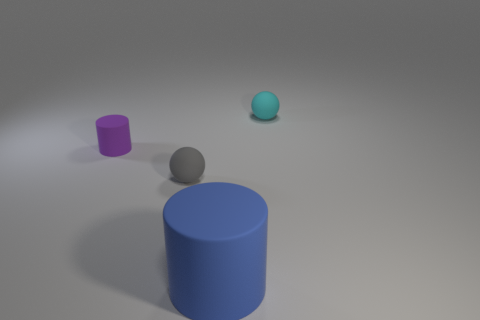There is a small rubber object that is to the right of the big object; are there any blue things to the right of it?
Offer a terse response. No. The object on the right side of the large blue matte cylinder has what shape?
Your answer should be compact. Sphere. What is the color of the small object to the right of the rubber cylinder that is in front of the tiny purple rubber thing?
Your answer should be very brief. Cyan. Does the purple rubber cylinder have the same size as the gray sphere?
Offer a very short reply. Yes. How many other things are the same size as the gray matte thing?
Provide a short and direct response. 2. The large cylinder that is made of the same material as the small purple object is what color?
Make the answer very short. Blue. Is the number of small gray matte spheres less than the number of cylinders?
Your answer should be compact. Yes. What number of gray things are either small matte things or small cylinders?
Keep it short and to the point. 1. How many objects are both on the right side of the gray sphere and behind the big blue rubber cylinder?
Keep it short and to the point. 1. What is the shape of the purple rubber thing that is the same size as the cyan matte sphere?
Keep it short and to the point. Cylinder. 